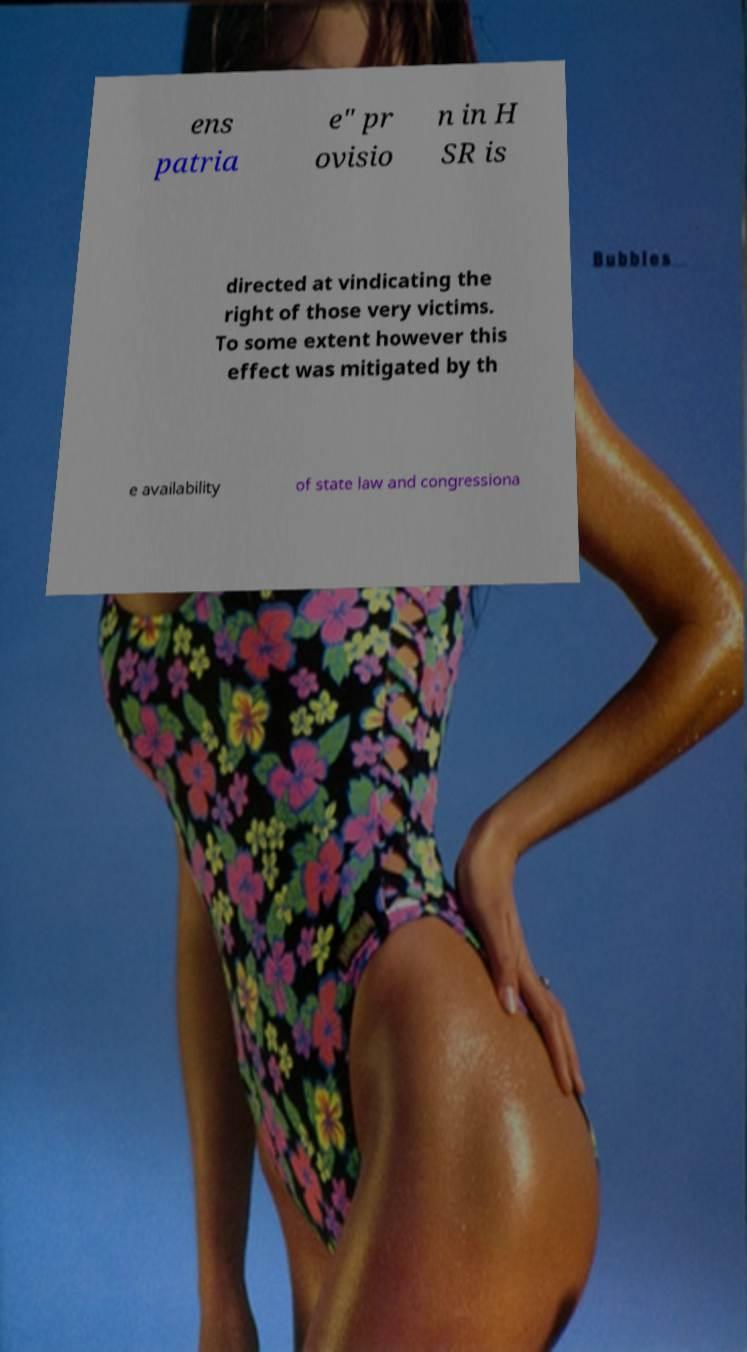Please identify and transcribe the text found in this image. ens patria e" pr ovisio n in H SR is directed at vindicating the right of those very victims. To some extent however this effect was mitigated by th e availability of state law and congressiona 